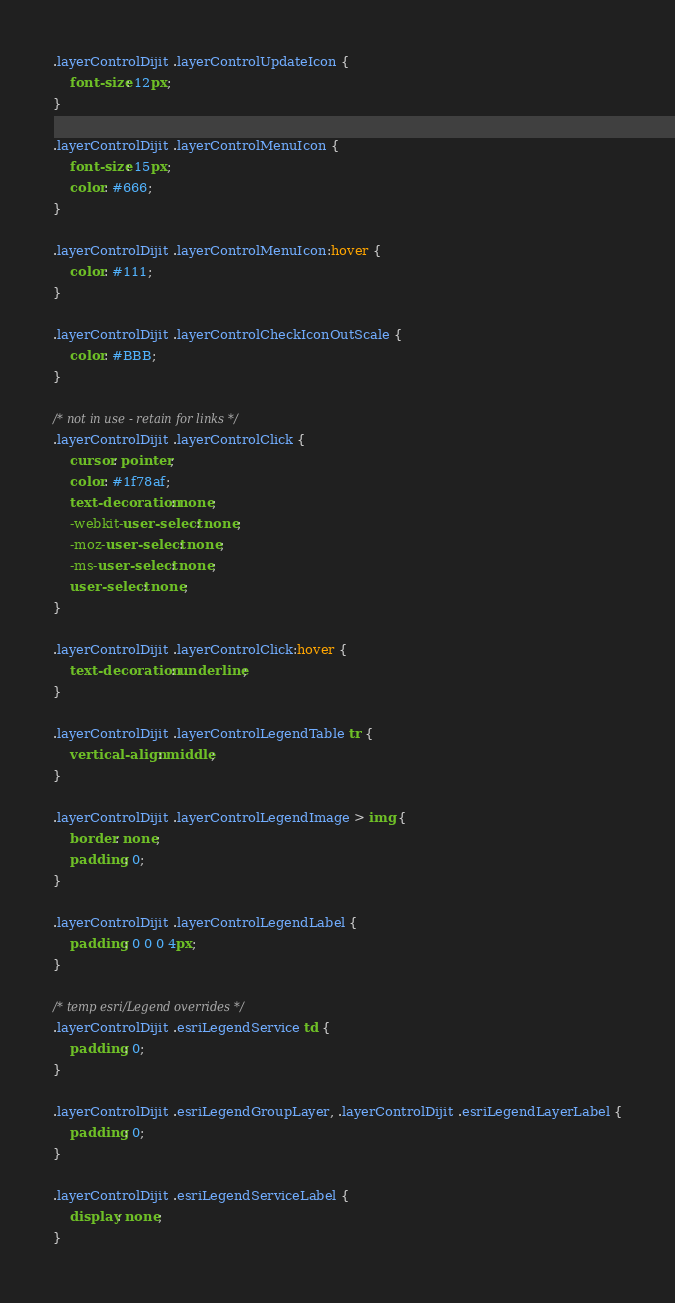Convert code to text. <code><loc_0><loc_0><loc_500><loc_500><_CSS_>.layerControlDijit .layerControlUpdateIcon {
    font-size: 12px;
}

.layerControlDijit .layerControlMenuIcon {
    font-size: 15px;
    color: #666;
}

.layerControlDijit .layerControlMenuIcon:hover {
    color: #111;
}

.layerControlDijit .layerControlCheckIconOutScale {
    color: #BBB;
}

/* not in use - retain for links */
.layerControlDijit .layerControlClick {
    cursor: pointer;
    color: #1f78af;
    text-decoration: none;
    -webkit-user-select: none;
    -moz-user-select: none;
    -ms-user-select: none;
    user-select: none;
}

.layerControlDijit .layerControlClick:hover {
    text-decoration: underline;
}

.layerControlDijit .layerControlLegendTable tr {
    vertical-align: middle;
}

.layerControlDijit .layerControlLegendImage > img {
    border: none;
    padding: 0;
}

.layerControlDijit .layerControlLegendLabel {
    padding: 0 0 0 4px;
}

/* temp esri/Legend overrides */
.layerControlDijit .esriLegendService td {
    padding: 0;
}

.layerControlDijit .esriLegendGroupLayer, .layerControlDijit .esriLegendLayerLabel {
    padding: 0;
}

.layerControlDijit .esriLegendServiceLabel {
    display: none;
}
</code> 